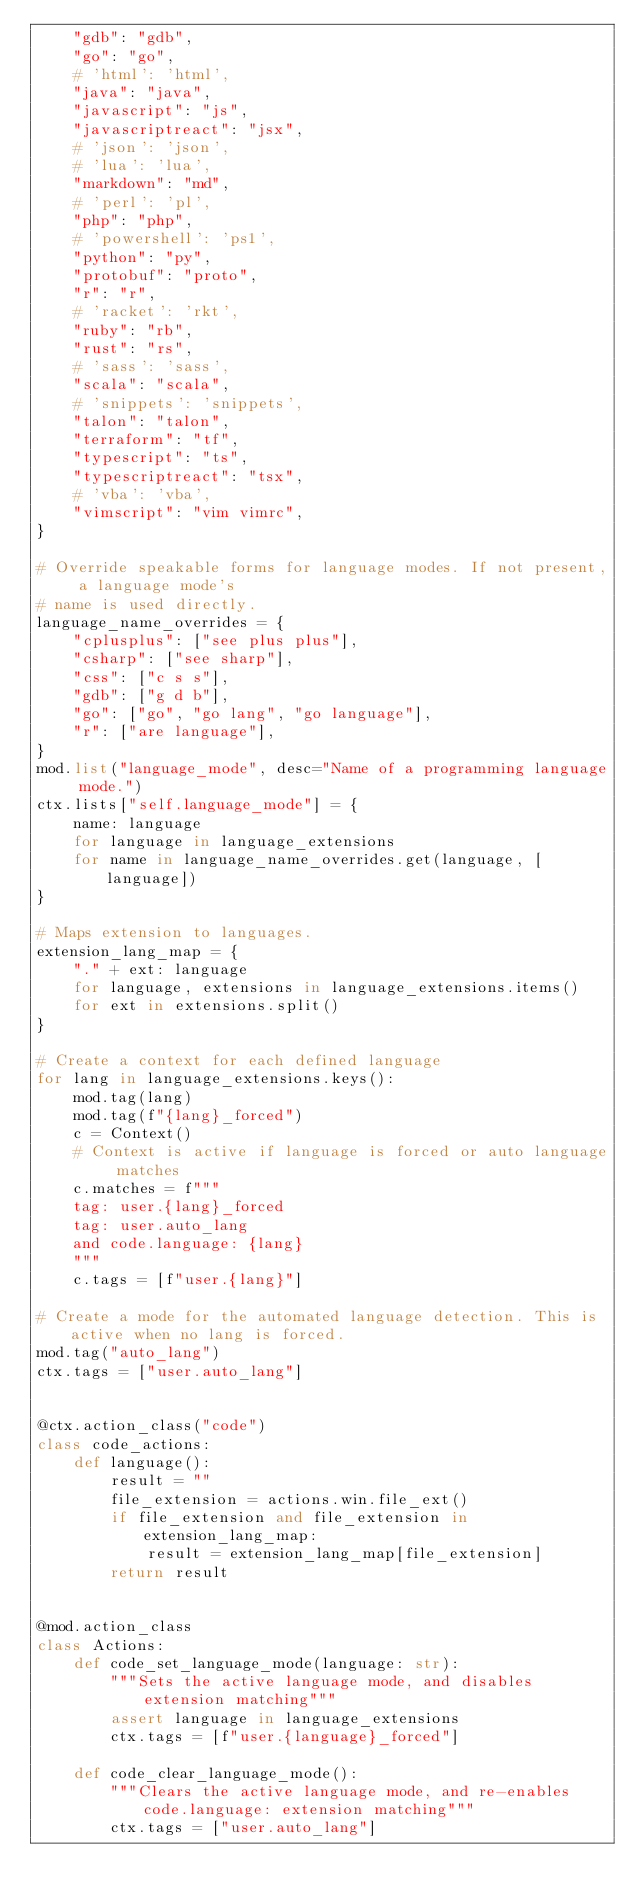<code> <loc_0><loc_0><loc_500><loc_500><_Python_>    "gdb": "gdb",
    "go": "go",
    # 'html': 'html',
    "java": "java",
    "javascript": "js",
    "javascriptreact": "jsx",
    # 'json': 'json',
    # 'lua': 'lua',
    "markdown": "md",
    # 'perl': 'pl',
    "php": "php",
    # 'powershell': 'ps1',
    "python": "py",
    "protobuf": "proto",
    "r": "r",
    # 'racket': 'rkt',
    "ruby": "rb",
    "rust": "rs",
    # 'sass': 'sass',
    "scala": "scala",
    # 'snippets': 'snippets',
    "talon": "talon",
    "terraform": "tf",
    "typescript": "ts",
    "typescriptreact": "tsx",
    # 'vba': 'vba',
    "vimscript": "vim vimrc",
}

# Override speakable forms for language modes. If not present, a language mode's
# name is used directly.
language_name_overrides = {
    "cplusplus": ["see plus plus"],
    "csharp": ["see sharp"],
    "css": ["c s s"],
    "gdb": ["g d b"],
    "go": ["go", "go lang", "go language"],
    "r": ["are language"],
}
mod.list("language_mode", desc="Name of a programming language mode.")
ctx.lists["self.language_mode"] = {
    name: language
    for language in language_extensions
    for name in language_name_overrides.get(language, [language])
}

# Maps extension to languages.
extension_lang_map = {
    "." + ext: language
    for language, extensions in language_extensions.items()
    for ext in extensions.split()
}

# Create a context for each defined language
for lang in language_extensions.keys():
    mod.tag(lang)
    mod.tag(f"{lang}_forced")
    c = Context()
    # Context is active if language is forced or auto language matches
    c.matches = f"""
    tag: user.{lang}_forced
    tag: user.auto_lang
    and code.language: {lang}
    """
    c.tags = [f"user.{lang}"]

# Create a mode for the automated language detection. This is active when no lang is forced.
mod.tag("auto_lang")
ctx.tags = ["user.auto_lang"]


@ctx.action_class("code")
class code_actions:
    def language():
        result = ""
        file_extension = actions.win.file_ext()
        if file_extension and file_extension in extension_lang_map:
            result = extension_lang_map[file_extension]
        return result


@mod.action_class
class Actions:
    def code_set_language_mode(language: str):
        """Sets the active language mode, and disables extension matching"""
        assert language in language_extensions
        ctx.tags = [f"user.{language}_forced"]

    def code_clear_language_mode():
        """Clears the active language mode, and re-enables code.language: extension matching"""
        ctx.tags = ["user.auto_lang"]
</code> 